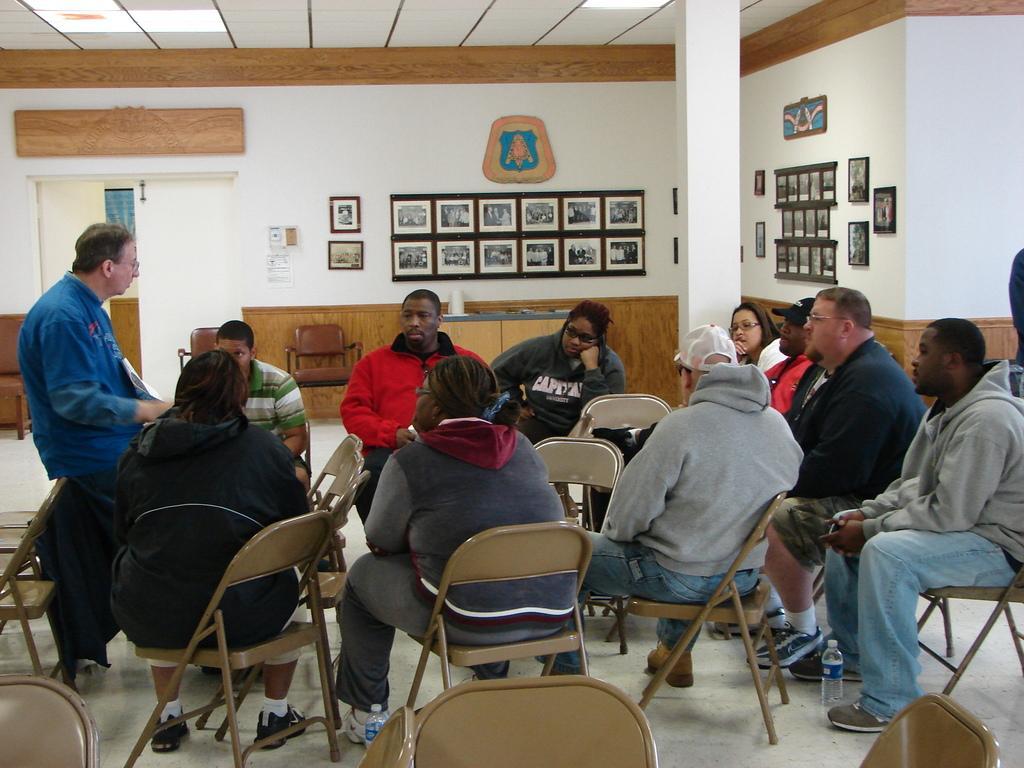How would you summarize this image in a sentence or two? In this image we have group of people who are sitting on the chair, among them on the left side of the image we have a person who is the man is wearing a blue shirt is standing and behind these people we have a white color wall. On the wall we have some wall photos on it, we also have a white color pillar. 